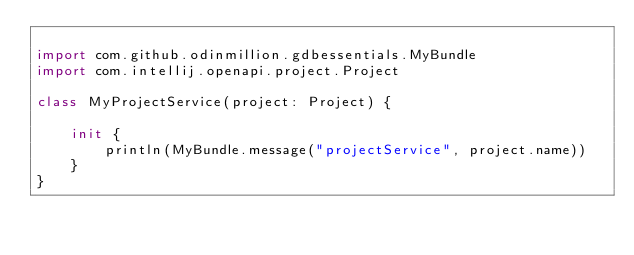<code> <loc_0><loc_0><loc_500><loc_500><_Kotlin_>
import com.github.odinmillion.gdbessentials.MyBundle
import com.intellij.openapi.project.Project

class MyProjectService(project: Project) {

    init {
        println(MyBundle.message("projectService", project.name))
    }
}
</code> 